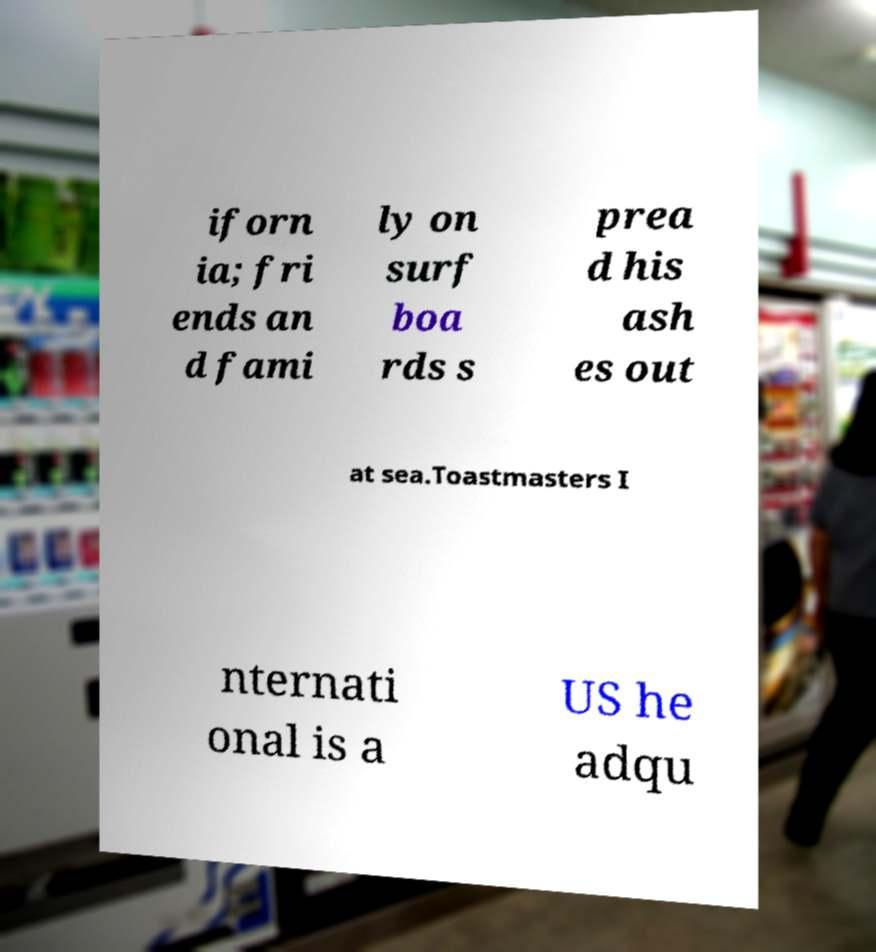Can you read and provide the text displayed in the image?This photo seems to have some interesting text. Can you extract and type it out for me? iforn ia; fri ends an d fami ly on surf boa rds s prea d his ash es out at sea.Toastmasters I nternati onal is a US he adqu 